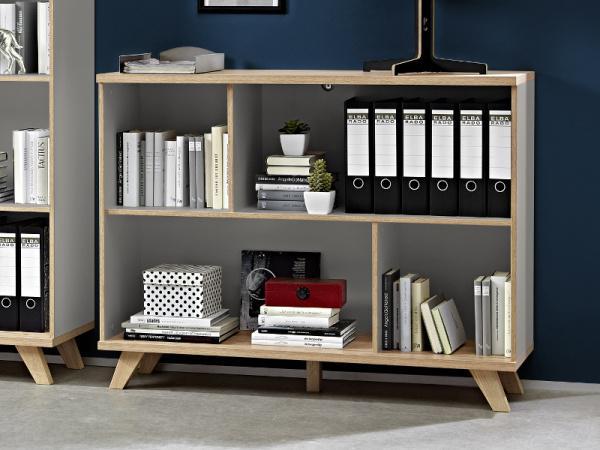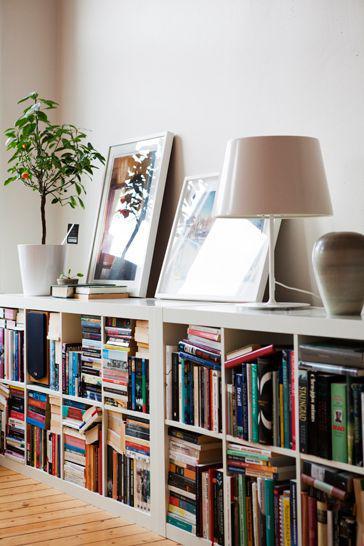The first image is the image on the left, the second image is the image on the right. For the images shown, is this caption "At least one image shows a white low bookshelf unit that sits flush on the ground and has a variety of items displayed on its top." true? Answer yes or no. Yes. The first image is the image on the left, the second image is the image on the right. Considering the images on both sides, is "The bookshelf in the image on the left is sitting against a white wall." valid? Answer yes or no. No. 